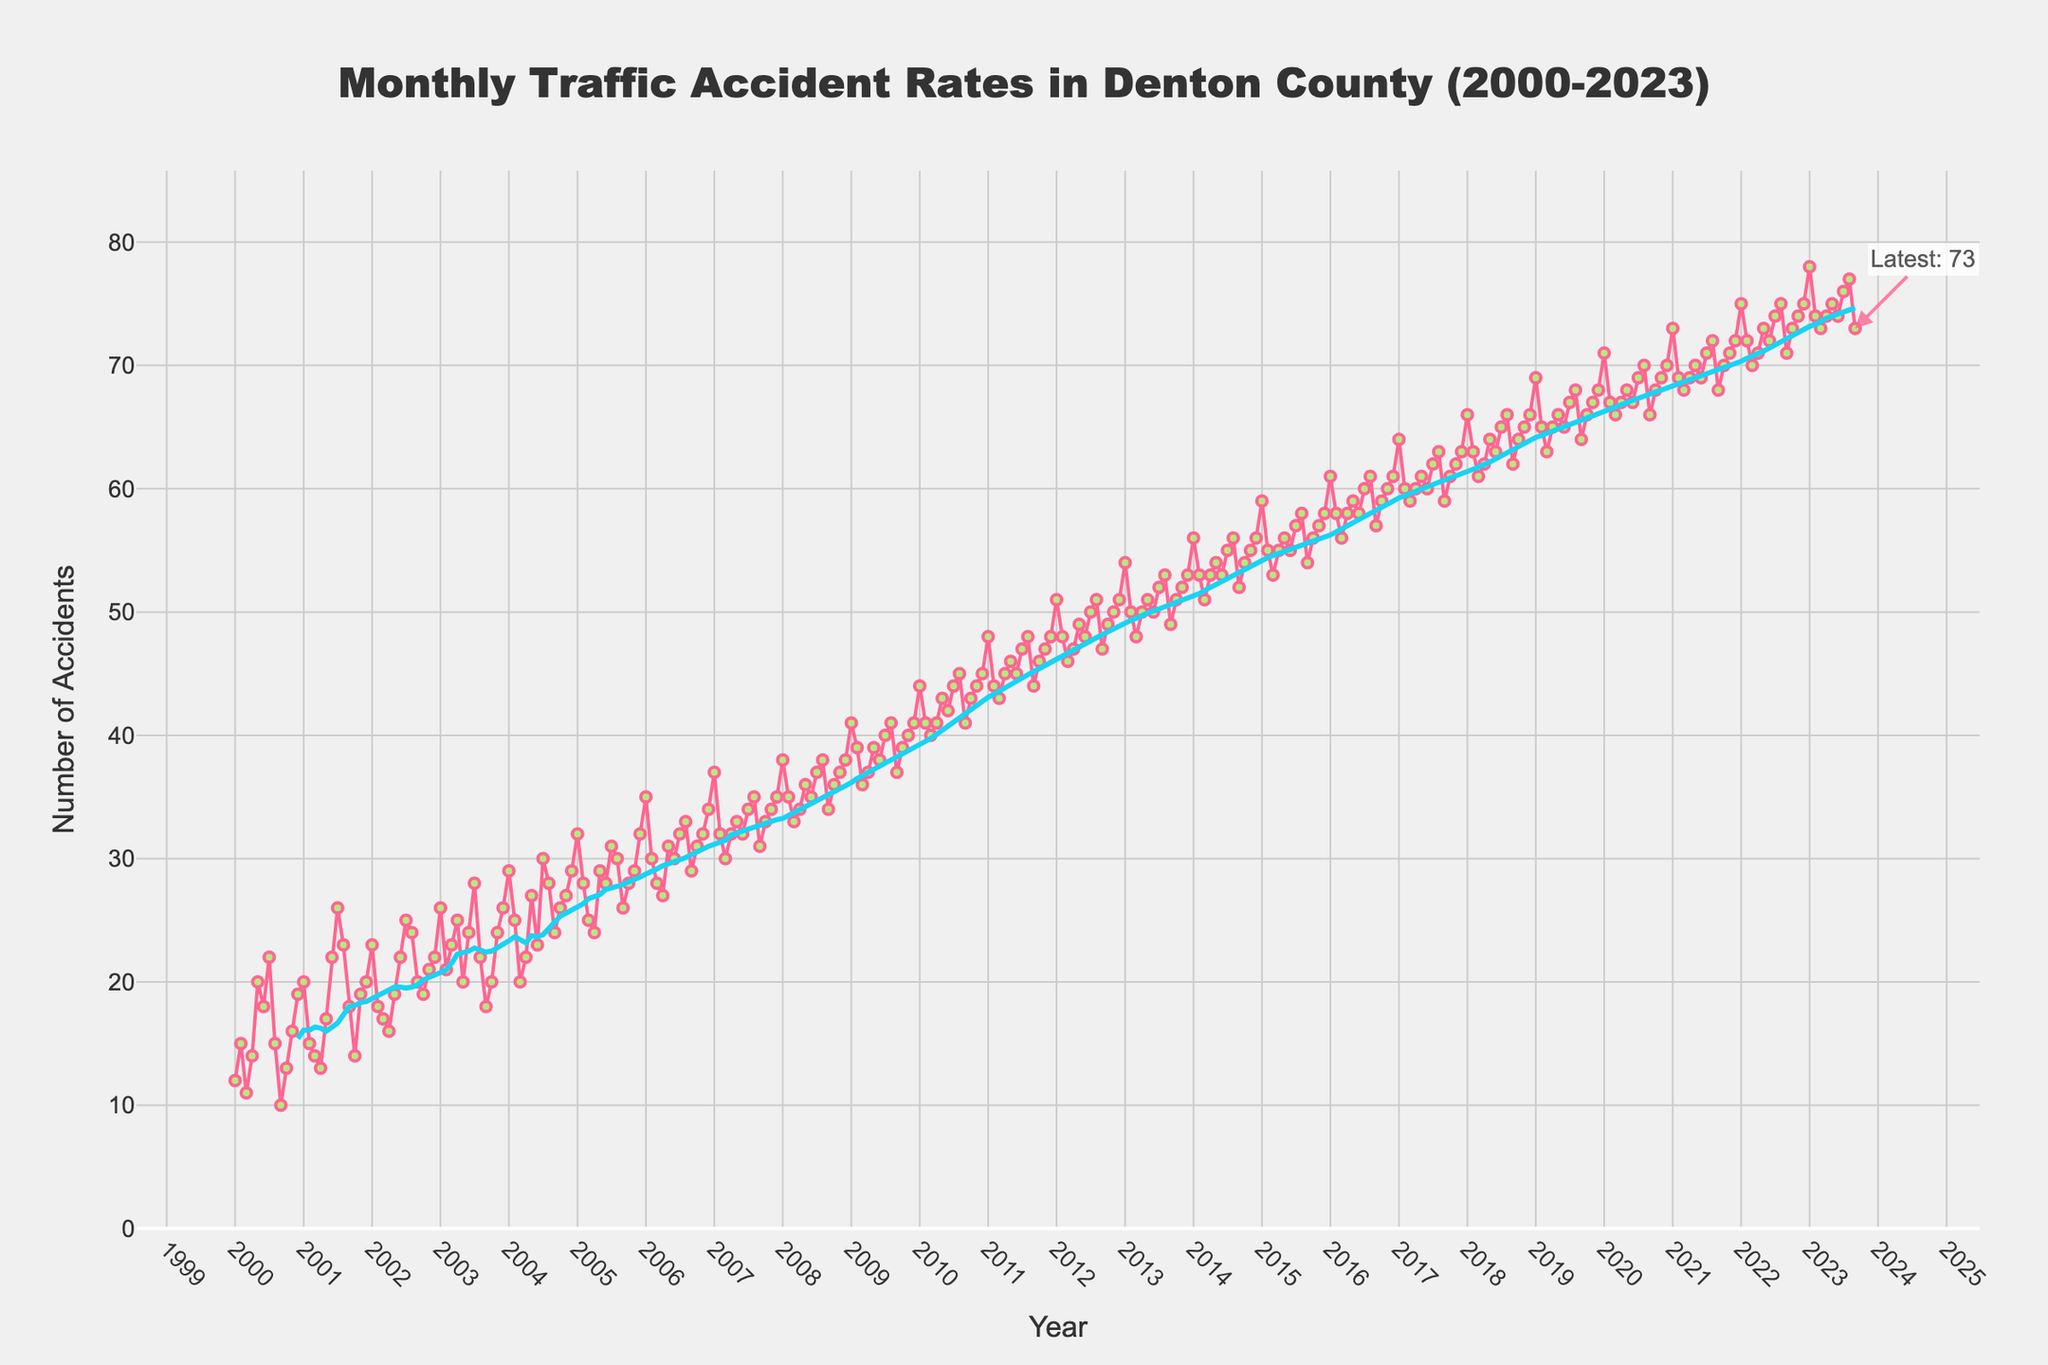How many data points are there in the figure? Count the number of data points from January 2000 to September 2023. Each data point represents one month. There are 23 (years) * 12 (months) = 276 plus an additional 9 months, which totals 285 data points.
Answer: 285 What is the title of the figure? Read the title text at the top of the plot. The title clearly identifies the subject of the plot.
Answer: Monthly Traffic Accident Rates in Denton County (2000-2023) What is the color of the line representing the accident rates? Identify the color of the line on the plot that traces the number of accidents. The line color is a prominent visual element.
Answer: Pink Which month and year had the highest number of accidents, and what was the value? Identify the highest point on the plot where the number of accidents is the maximum. The annotation at the end of the plot helps in locating this.
Answer: January 2023, 78 How does the number of accidents in January 2000 compare with January 2023? See the values in the plot for January 2000 and January 2023 and compare them to note the increase. January 2000 shows 12 accidents while January 2023 shows 78 accidents.
Answer: January 2023 has significantly more accidents What is the trend of traffic accidents over the years according to the 12-month moving average? Observe the 12-month moving average line added to the plot which smooths out short-term fluctuations. This line shows a general upward trend over the years.
Answer: Upward trend How do the number of accidents in 2010 compare with those in 2020? Observe and compare values from 2010 (starts at 44 in January) and 2020 (starts at 71 in January). There's a clear increase from 2010 to 2020.
Answer: Higher in 2020 Look at the periods 2000-2005 and 2018-2023. How do the accident rates differ between these two periods? Compare the average accident rate in 2000-2005 and 2018-2023. Visually, it's higher in the latter period. Detailed observation shows less than 35 in 2000-2005 mostly, and around 65 or more in 2018-2023.
Answer: Higher in 2018-2023 Are there any noticeable seasonal patterns in the accident rates yearly? Observe the month-to-month data for any repeating seasonal fluctuations. While individual months fluctuate, there is no clear, consistent seasonal pattern as the numbers gradually increase yearly.
Answer: No clear seasonal pattern 